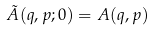Convert formula to latex. <formula><loc_0><loc_0><loc_500><loc_500>\tilde { A } ( q , p ; 0 ) = A ( q , p )</formula> 